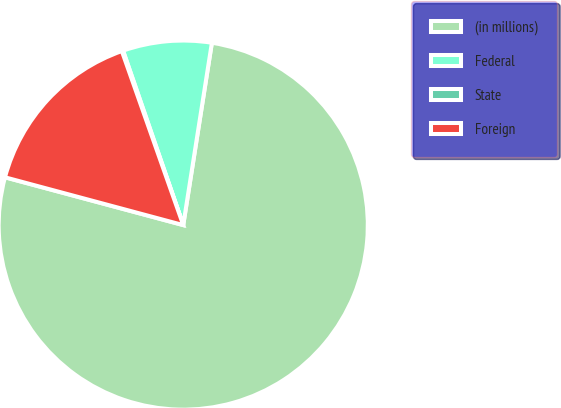<chart> <loc_0><loc_0><loc_500><loc_500><pie_chart><fcel>(in millions)<fcel>Federal<fcel>State<fcel>Foreign<nl><fcel>76.69%<fcel>7.77%<fcel>0.11%<fcel>15.43%<nl></chart> 